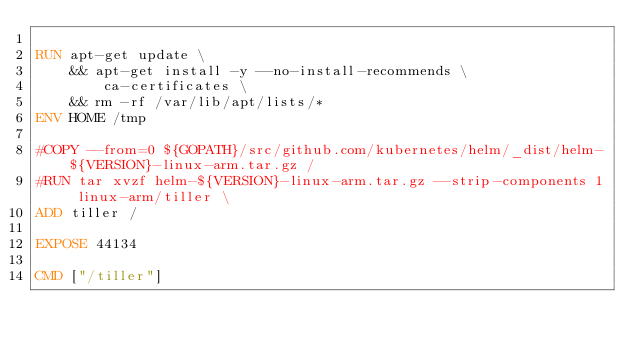<code> <loc_0><loc_0><loc_500><loc_500><_Dockerfile_>
RUN apt-get update \
	&& apt-get install -y --no-install-recommends \
		ca-certificates \
	&& rm -rf /var/lib/apt/lists/*
ENV HOME /tmp

#COPY --from=0 ${GOPATH}/src/github.com/kubernetes/helm/_dist/helm-${VERSION}-linux-arm.tar.gz /
#RUN tar xvzf helm-${VERSION}-linux-arm.tar.gz --strip-components 1 linux-arm/tiller \
ADD tiller /

EXPOSE 44134

CMD ["/tiller"]

    </code> 